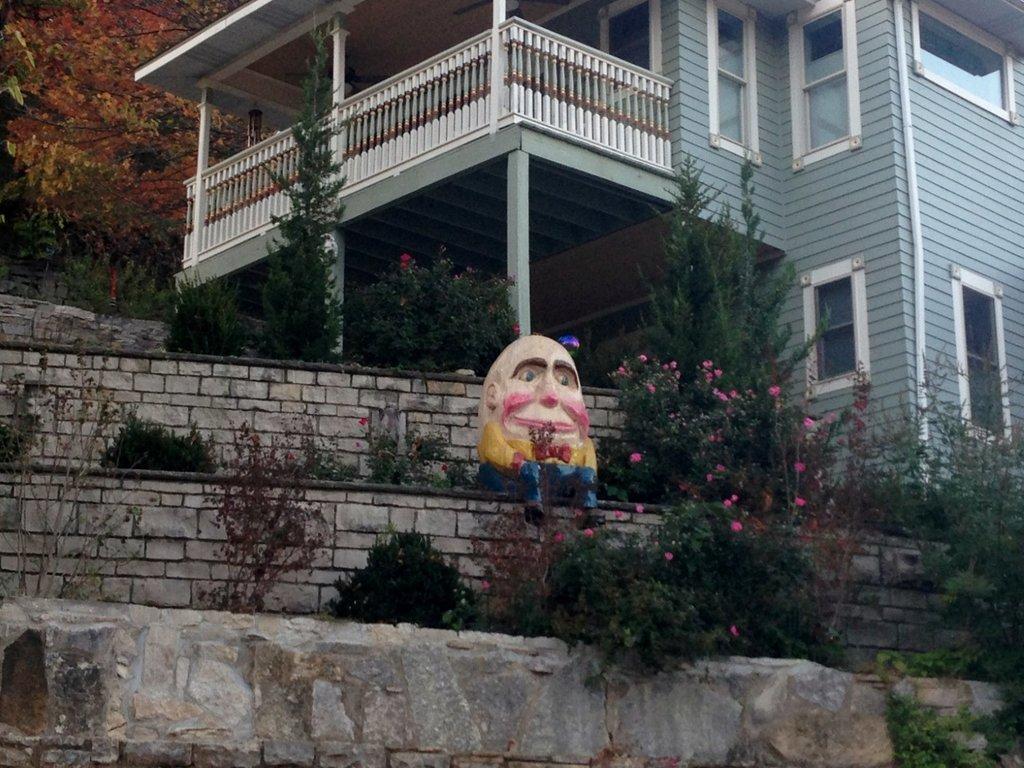Could you give a brief overview of what you see in this image? In this image there is a statue sitting on the wall. There are flower plants around it. In the background there is a building. At the bottom there is a stone wall. Beside the building there is a hill. At the bottom there are small plants. 